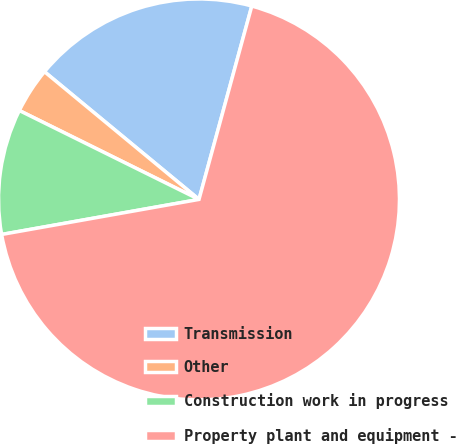<chart> <loc_0><loc_0><loc_500><loc_500><pie_chart><fcel>Transmission<fcel>Other<fcel>Construction work in progress<fcel>Property plant and equipment -<nl><fcel>18.25%<fcel>3.68%<fcel>10.11%<fcel>67.96%<nl></chart> 